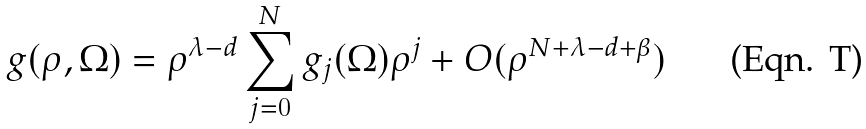Convert formula to latex. <formula><loc_0><loc_0><loc_500><loc_500>g ( \rho , \Omega ) = \rho ^ { \lambda - d } \sum _ { j = 0 } ^ { N } g _ { j } ( \Omega ) \rho ^ { j } + O ( \rho ^ { N + \lambda - d + \beta } )</formula> 